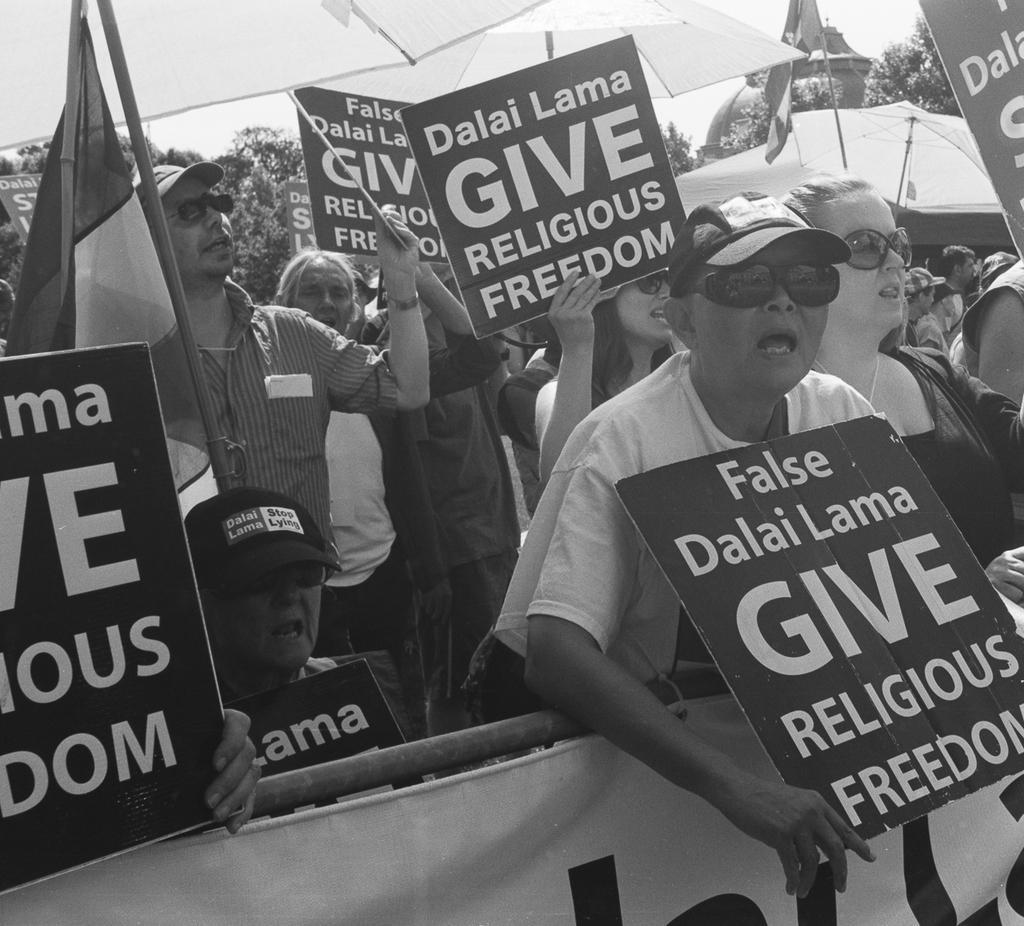Can you describe this image briefly? This picture is clicked outside. In the foreground we can see the text on the banner and on the boards and we can see the metal rod, flag attached to the pole, umbrellas and group of persons holding the boards and standing. In the background we can see the sky, trees and some other objects. 